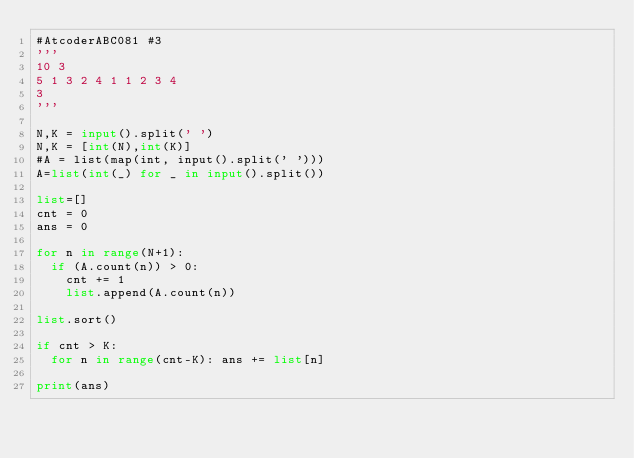Convert code to text. <code><loc_0><loc_0><loc_500><loc_500><_Python_>#AtcoderABC081 #3
'''
10 3
5 1 3 2 4 1 1 2 3 4
3
'''

N,K = input().split(' ')
N,K = [int(N),int(K)]
#A = list(map(int, input().split(' ')))
A=list(int(_) for _ in input().split()) 

list=[]
cnt = 0
ans = 0

for n in range(N+1):
	if (A.count(n)) > 0:
		cnt += 1
		list.append(A.count(n))

list.sort()

if cnt > K:
	for n in range(cnt-K): ans += list[n] 

print(ans)</code> 